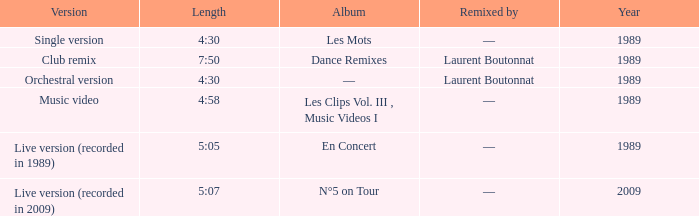What was the minimum year for album of les mots? 1989.0. 